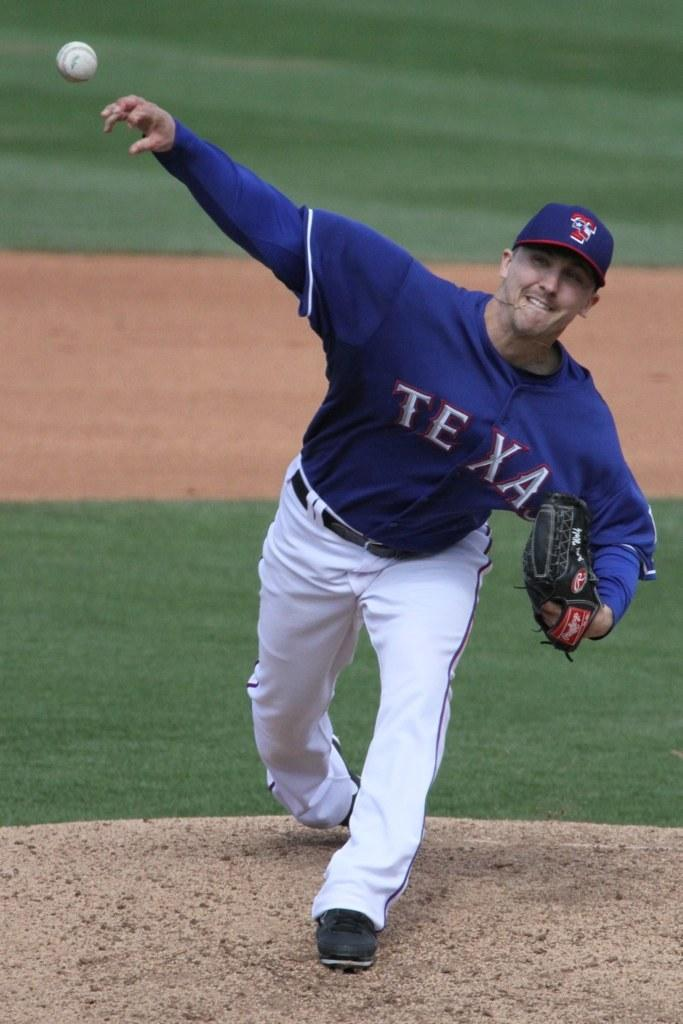Provide a one-sentence caption for the provided image. A baseball player with the word Texas on his shirt throws a baseball. 